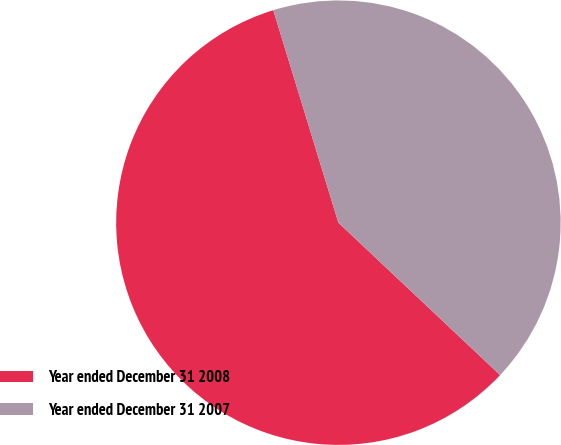Convert chart to OTSL. <chart><loc_0><loc_0><loc_500><loc_500><pie_chart><fcel>Year ended December 31 2008<fcel>Year ended December 31 2007<nl><fcel>58.24%<fcel>41.76%<nl></chart> 